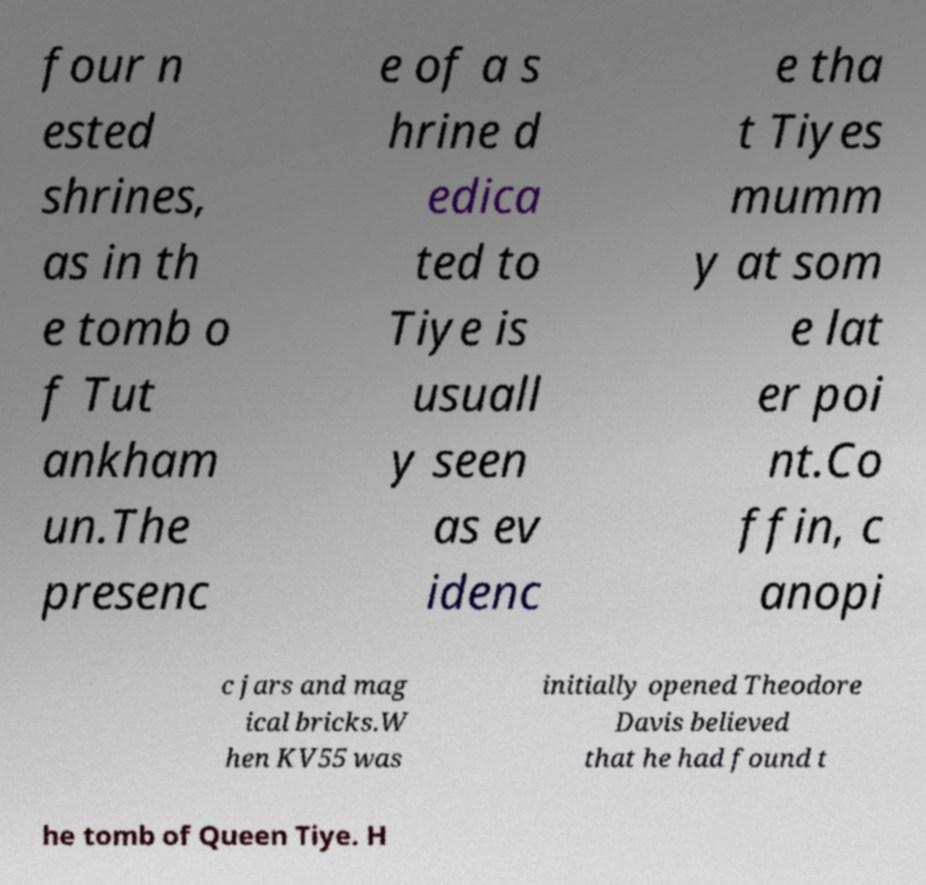There's text embedded in this image that I need extracted. Can you transcribe it verbatim? four n ested shrines, as in th e tomb o f Tut ankham un.The presenc e of a s hrine d edica ted to Tiye is usuall y seen as ev idenc e tha t Tiyes mumm y at som e lat er poi nt.Co ffin, c anopi c jars and mag ical bricks.W hen KV55 was initially opened Theodore Davis believed that he had found t he tomb of Queen Tiye. H 